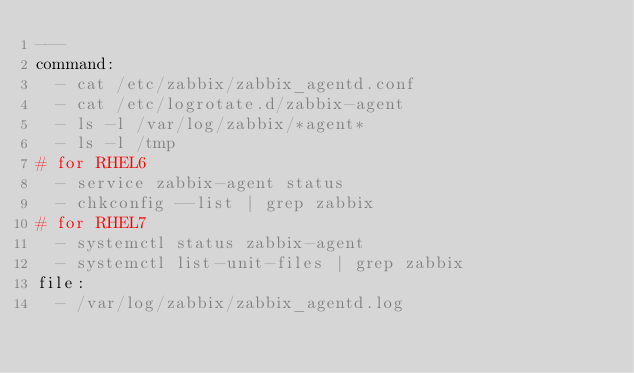Convert code to text. <code><loc_0><loc_0><loc_500><loc_500><_YAML_>---
command:
  - cat /etc/zabbix/zabbix_agentd.conf
  - cat /etc/logrotate.d/zabbix-agent
  - ls -l /var/log/zabbix/*agent*
  - ls -l /tmp
# for RHEL6
  - service zabbix-agent status
  - chkconfig --list | grep zabbix
# for RHEL7
  - systemctl status zabbix-agent
  - systemctl list-unit-files | grep zabbix
file:
  - /var/log/zabbix/zabbix_agentd.log
</code> 